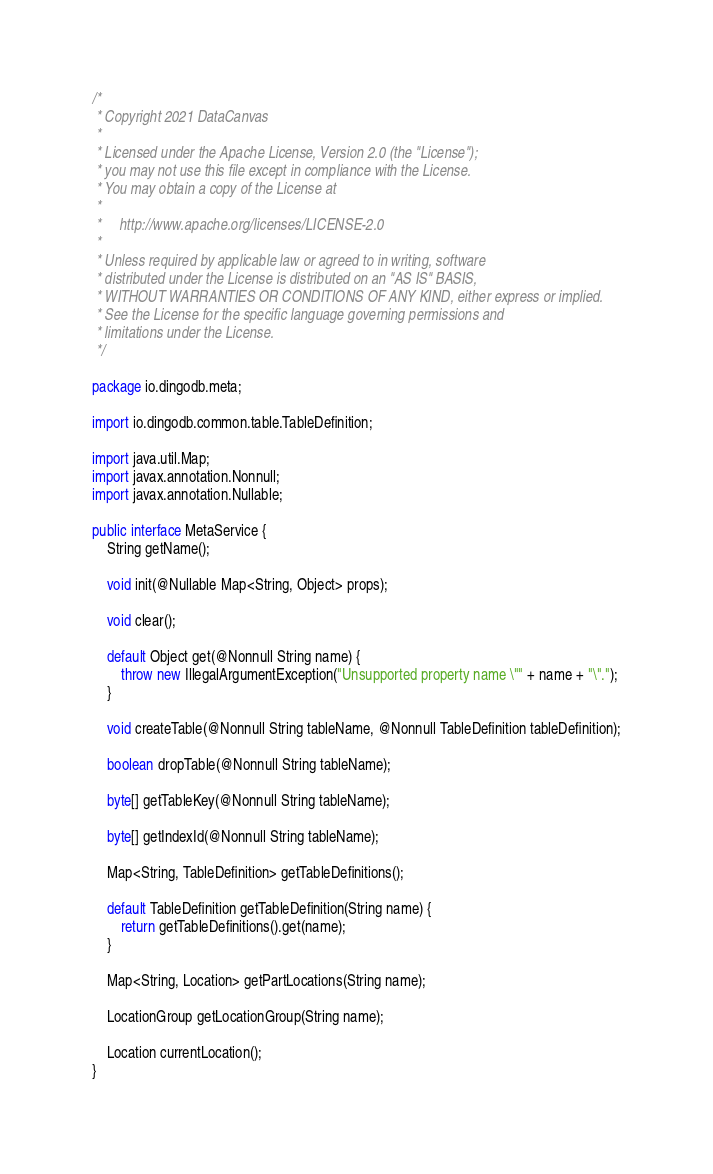<code> <loc_0><loc_0><loc_500><loc_500><_Java_>/*
 * Copyright 2021 DataCanvas
 *
 * Licensed under the Apache License, Version 2.0 (the "License");
 * you may not use this file except in compliance with the License.
 * You may obtain a copy of the License at
 *
 *     http://www.apache.org/licenses/LICENSE-2.0
 *
 * Unless required by applicable law or agreed to in writing, software
 * distributed under the License is distributed on an "AS IS" BASIS,
 * WITHOUT WARRANTIES OR CONDITIONS OF ANY KIND, either express or implied.
 * See the License for the specific language governing permissions and
 * limitations under the License.
 */

package io.dingodb.meta;

import io.dingodb.common.table.TableDefinition;

import java.util.Map;
import javax.annotation.Nonnull;
import javax.annotation.Nullable;

public interface MetaService {
    String getName();

    void init(@Nullable Map<String, Object> props);

    void clear();

    default Object get(@Nonnull String name) {
        throw new IllegalArgumentException("Unsupported property name \"" + name + "\".");
    }

    void createTable(@Nonnull String tableName, @Nonnull TableDefinition tableDefinition);

    boolean dropTable(@Nonnull String tableName);

    byte[] getTableKey(@Nonnull String tableName);

    byte[] getIndexId(@Nonnull String tableName);

    Map<String, TableDefinition> getTableDefinitions();

    default TableDefinition getTableDefinition(String name) {
        return getTableDefinitions().get(name);
    }

    Map<String, Location> getPartLocations(String name);

    LocationGroup getLocationGroup(String name);

    Location currentLocation();
}
</code> 